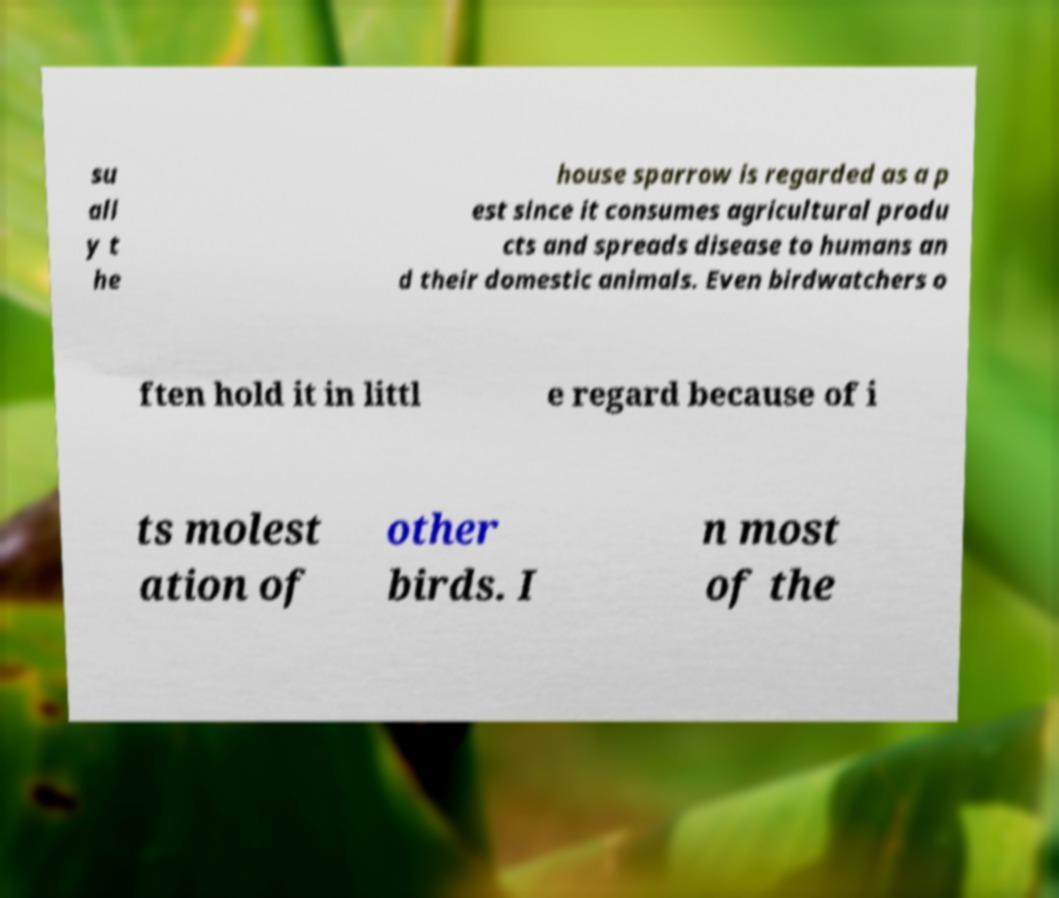Please identify and transcribe the text found in this image. su all y t he house sparrow is regarded as a p est since it consumes agricultural produ cts and spreads disease to humans an d their domestic animals. Even birdwatchers o ften hold it in littl e regard because of i ts molest ation of other birds. I n most of the 